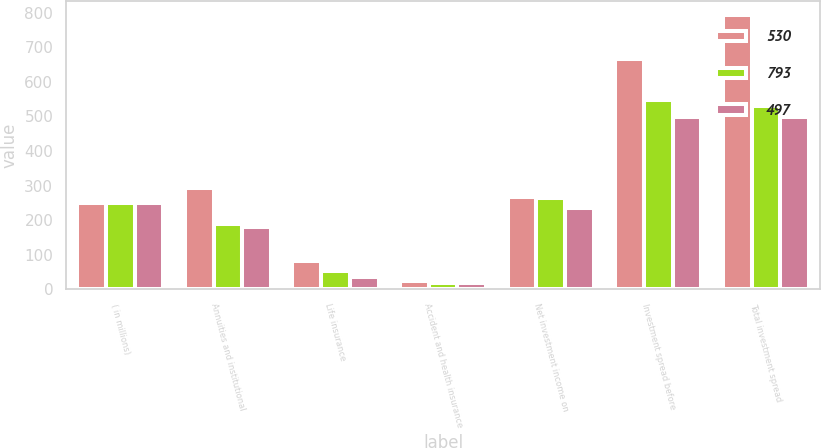<chart> <loc_0><loc_0><loc_500><loc_500><stacked_bar_chart><ecel><fcel>( in millions)<fcel>Annuities and institutional<fcel>Life insurance<fcel>Accident and health insurance<fcel>Net investment income on<fcel>Investment spread before<fcel>Total investment spread<nl><fcel>530<fcel>249.5<fcel>292<fcel>82<fcel>25<fcel>268<fcel>667<fcel>793<nl><fcel>793<fcel>249.5<fcel>188<fcel>54<fcel>19<fcel>265<fcel>548<fcel>530<nl><fcel>497<fcel>249.5<fcel>179<fcel>35<fcel>18<fcel>234<fcel>497<fcel>497<nl></chart> 